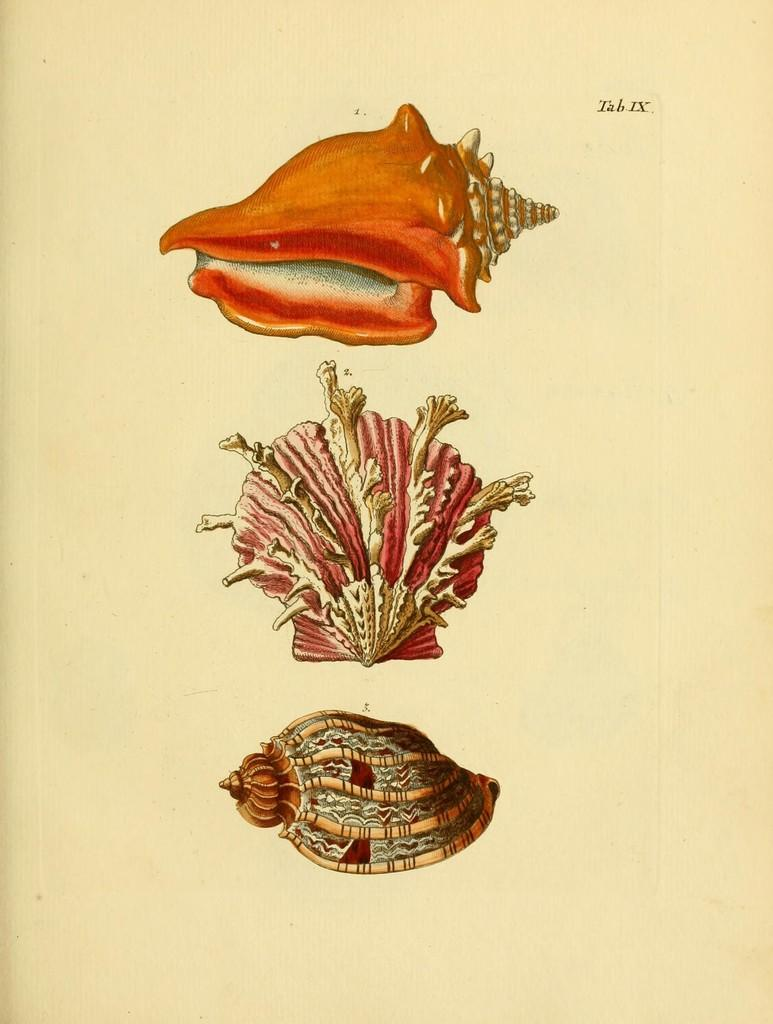What type of objects are depicted in the images in the picture? There are images of shells in the image. What else can be seen in the image besides the shells? There is text on a paper in the image. What type of cake is being prepared in the image? There is no cake present in the image; it features images of shells and text on a paper. 